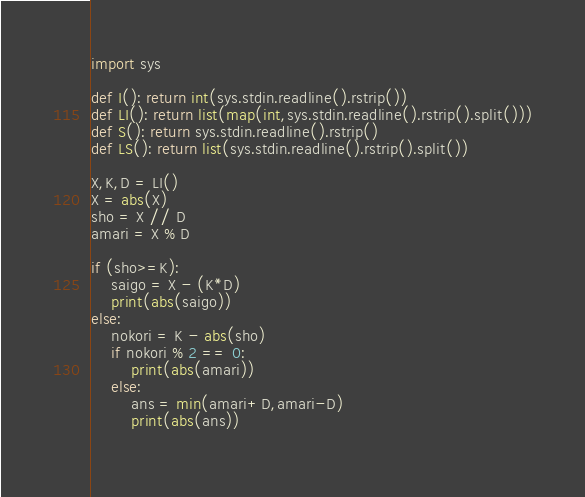<code> <loc_0><loc_0><loc_500><loc_500><_Python_>import sys

def I(): return int(sys.stdin.readline().rstrip())
def LI(): return list(map(int,sys.stdin.readline().rstrip().split()))
def S(): return sys.stdin.readline().rstrip()
def LS(): return list(sys.stdin.readline().rstrip().split())

X,K,D = LI()
X = abs(X)
sho = X // D
amari = X % D

if (sho>=K):
    saigo = X - (K*D)
    print(abs(saigo))
else:
    nokori = K - abs(sho)
    if nokori % 2 == 0:
        print(abs(amari))
    else:
        ans = min(amari+D,amari-D)
        print(abs(ans))
        </code> 